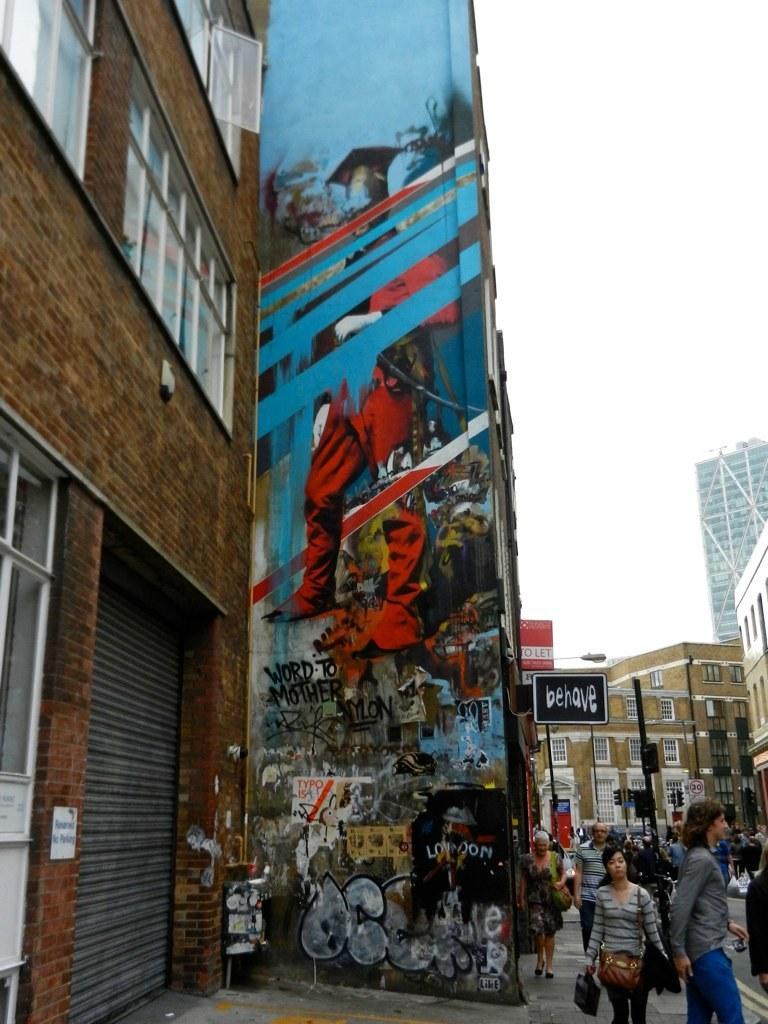Describe this image in one or two sentences. In this picture we can see a group of people, shutter, name boards, bags, painting on the wall, buildings with windows and some objects and in the background we can see the sky. 